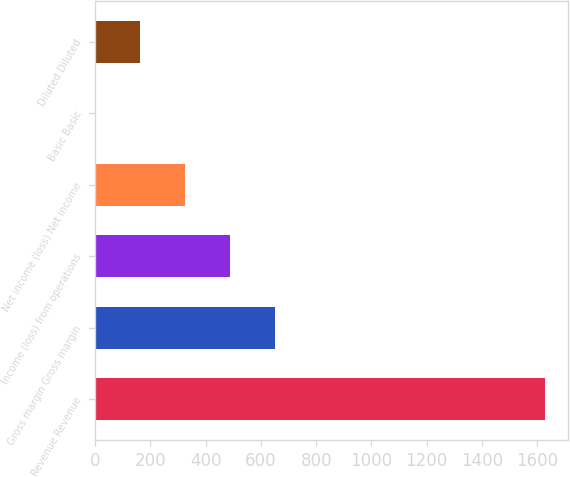Convert chart. <chart><loc_0><loc_0><loc_500><loc_500><bar_chart><fcel>Revenue Revenue<fcel>Gross margin Gross margin<fcel>Income (loss) from operations<fcel>Net income (loss) Net income<fcel>Basic Basic<fcel>Diluted Diluted<nl><fcel>1629<fcel>651.79<fcel>488.92<fcel>326.05<fcel>0.31<fcel>163.18<nl></chart> 